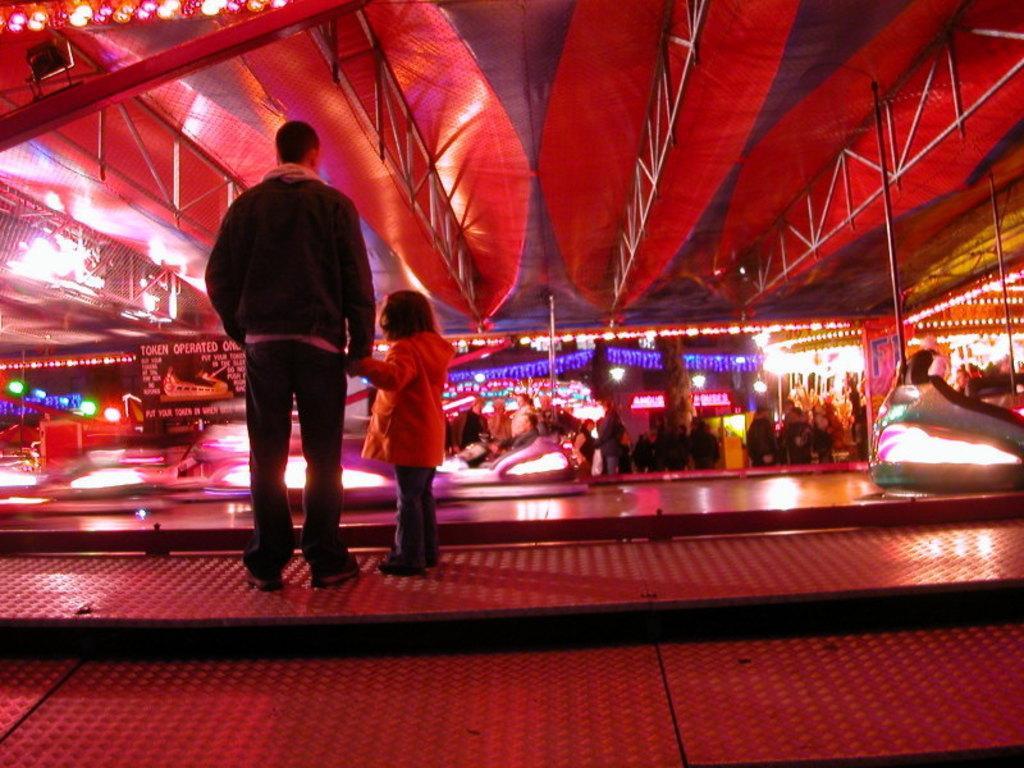Can you describe this image briefly? In the center of the image there is a person standing and there is child. In the background of the image there are many people. 